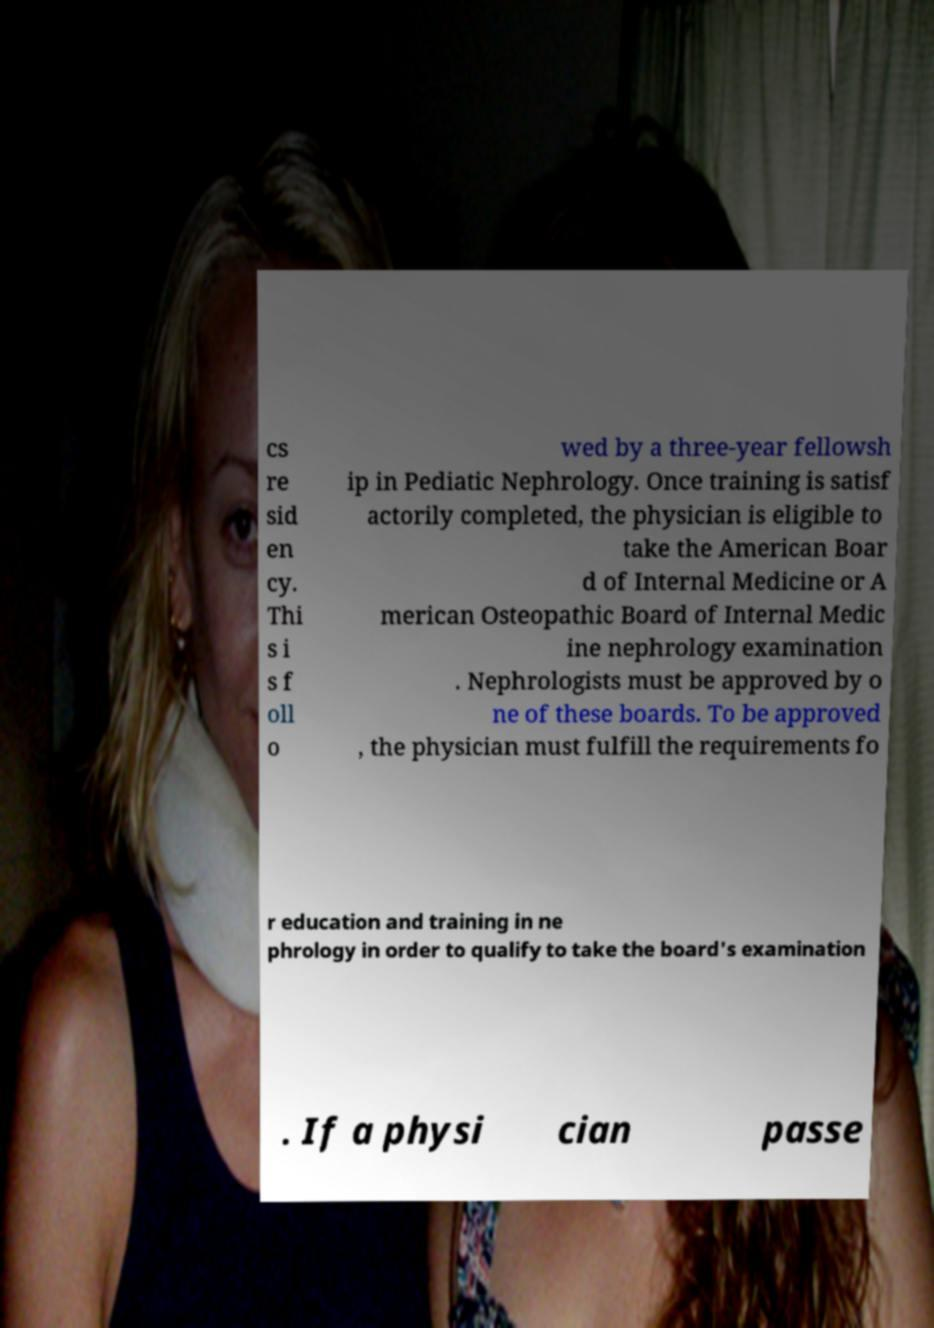There's text embedded in this image that I need extracted. Can you transcribe it verbatim? cs re sid en cy. Thi s i s f oll o wed by a three-year fellowsh ip in Pediatic Nephrology. Once training is satisf actorily completed, the physician is eligible to take the American Boar d of Internal Medicine or A merican Osteopathic Board of Internal Medic ine nephrology examination . Nephrologists must be approved by o ne of these boards. To be approved , the physician must fulfill the requirements fo r education and training in ne phrology in order to qualify to take the board's examination . If a physi cian passe 